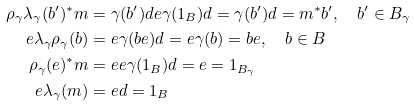<formula> <loc_0><loc_0><loc_500><loc_500>\rho _ { \gamma } \lambda _ { \gamma } ( b ^ { \prime } ) ^ { * } m & = \gamma ( b ^ { \prime } ) d e \gamma ( 1 _ { B } ) d = \gamma ( b ^ { \prime } ) d = m ^ { * } b ^ { \prime } , \quad b ^ { \prime } \in B _ { \gamma } \\ e \lambda _ { \gamma } \rho _ { \gamma } ( b ) & = e \gamma ( b e ) d = e \gamma ( b ) = b e , \quad b \in B \\ \rho _ { \gamma } ( e ) ^ { * } m & = e e \gamma ( 1 _ { B } ) d = e = 1 _ { B _ { \gamma } } \\ e \lambda _ { \gamma } ( m ) & = e d = 1 _ { B }</formula> 